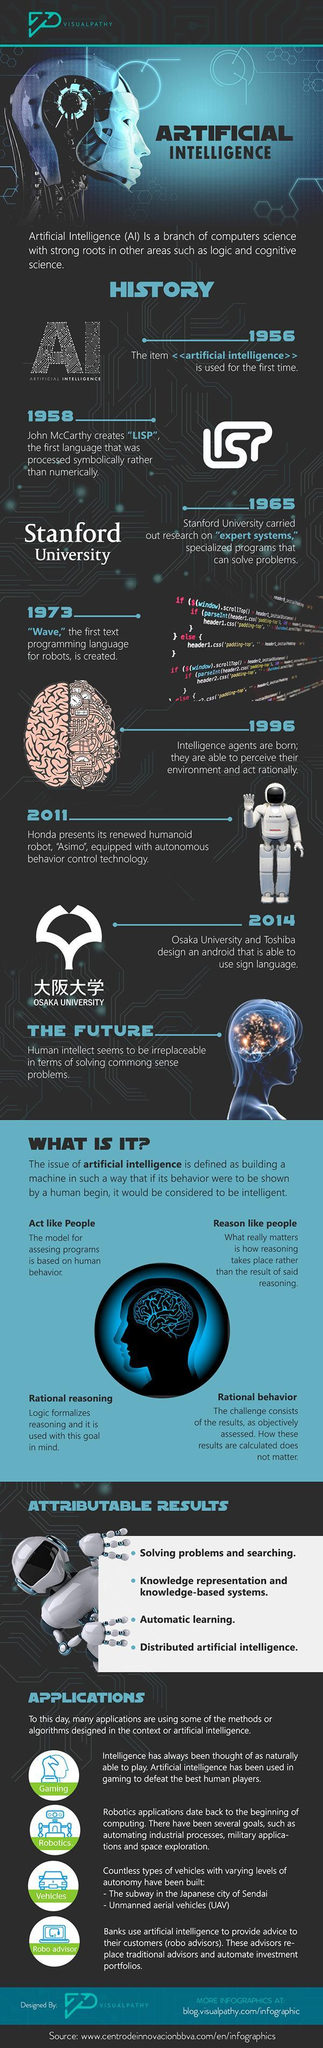Which is the second application of AI?
Answer the question with a short phrase. Robotics. How many applications of AI mentioned in this infographic? 4 Which is the third application of AI? Vehicles How many factors determines AI's intelligence? 4 